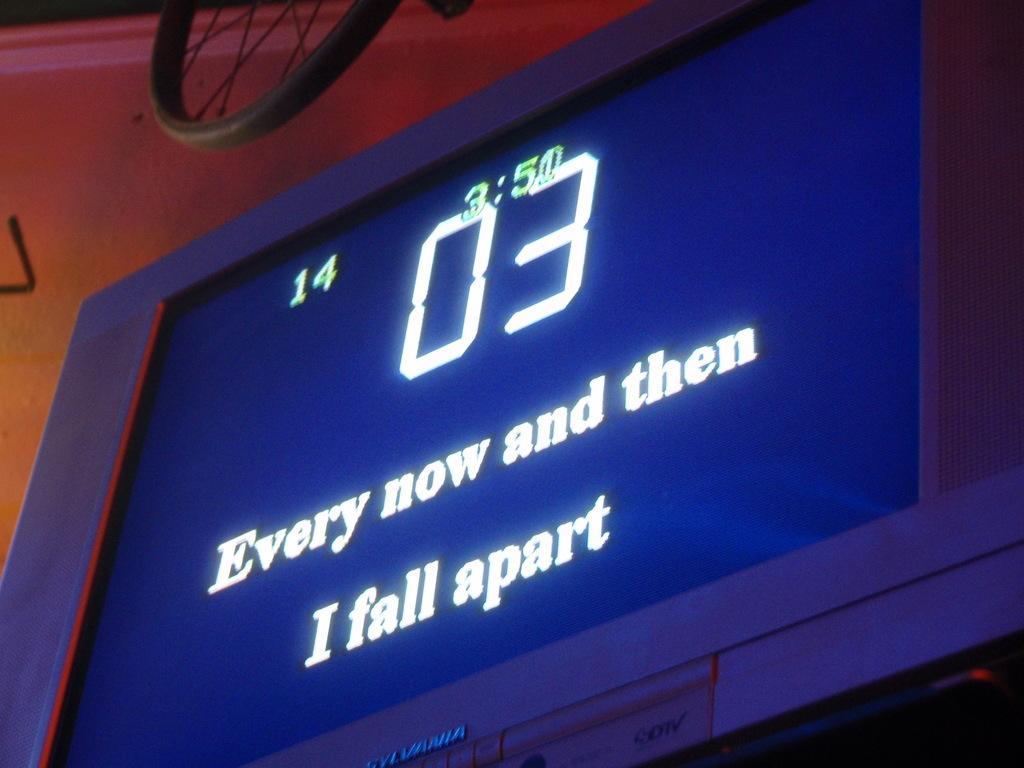<image>
Render a clear and concise summary of the photo. the letters 03 are on the blue board 